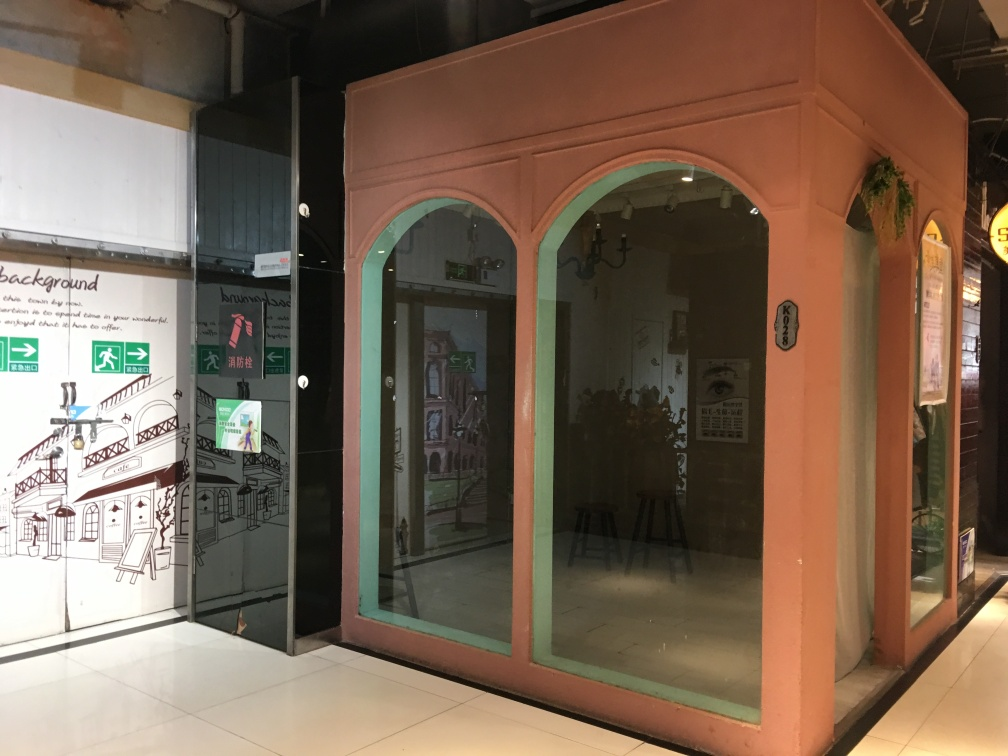What can you infer about the business behind the glass door? The interior behind the glass door appears to be a serene, possibly cultural space, with simple furnishing like stools and ambient lighting. It could be a small gallery, a studio, or a quiet café designed to provide a tranquil atmosphere. The signage and notices on the door suggest that it's likely a public space adhering to certain regulations. 